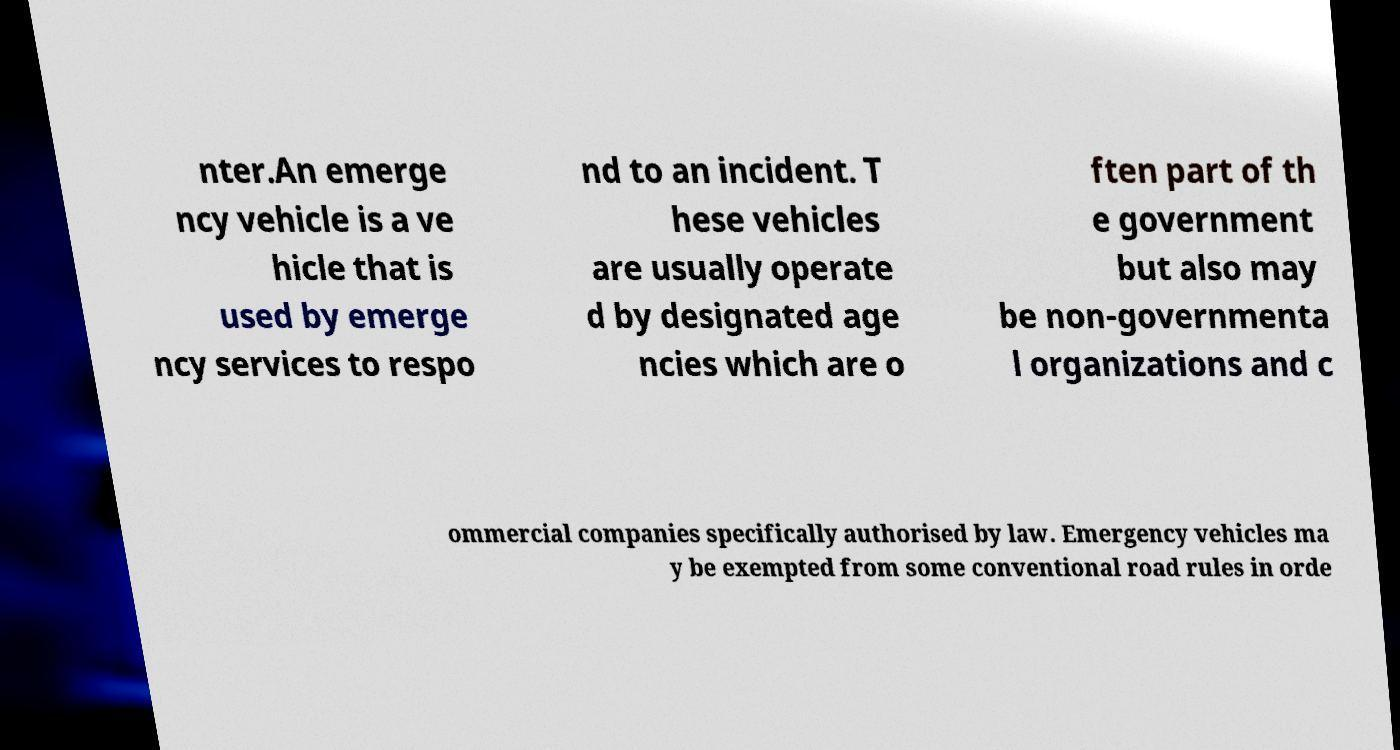I need the written content from this picture converted into text. Can you do that? nter.An emerge ncy vehicle is a ve hicle that is used by emerge ncy services to respo nd to an incident. T hese vehicles are usually operate d by designated age ncies which are o ften part of th e government but also may be non-governmenta l organizations and c ommercial companies specifically authorised by law. Emergency vehicles ma y be exempted from some conventional road rules in orde 